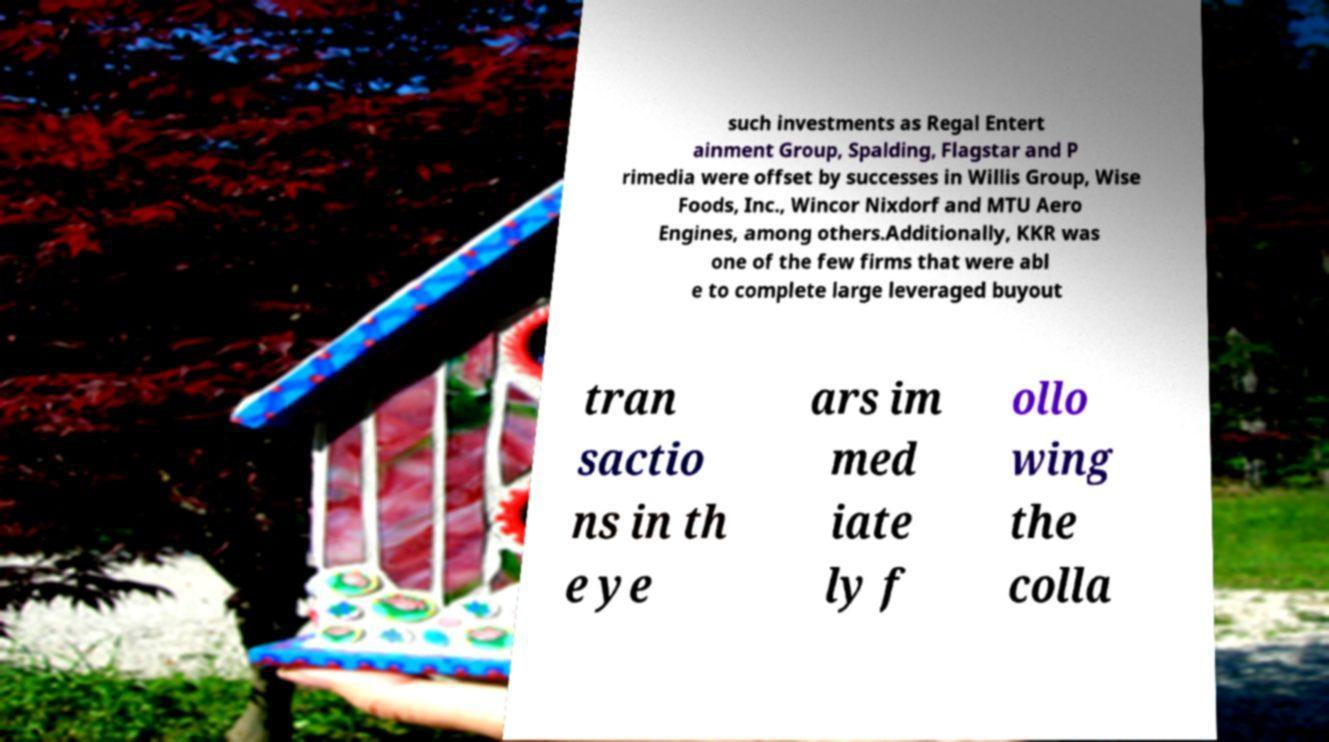Please identify and transcribe the text found in this image. such investments as Regal Entert ainment Group, Spalding, Flagstar and P rimedia were offset by successes in Willis Group, Wise Foods, Inc., Wincor Nixdorf and MTU Aero Engines, among others.Additionally, KKR was one of the few firms that were abl e to complete large leveraged buyout tran sactio ns in th e ye ars im med iate ly f ollo wing the colla 